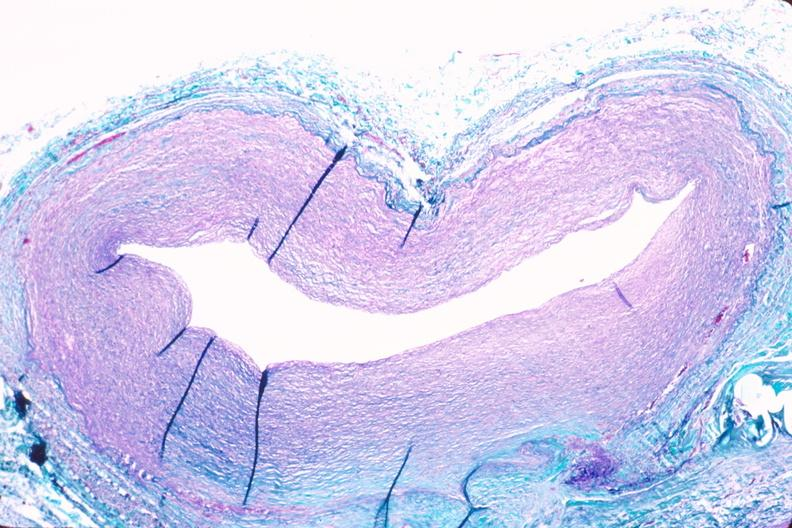what does this image show?
Answer the question using a single word or phrase. Saphenous vein graft sclerosis 